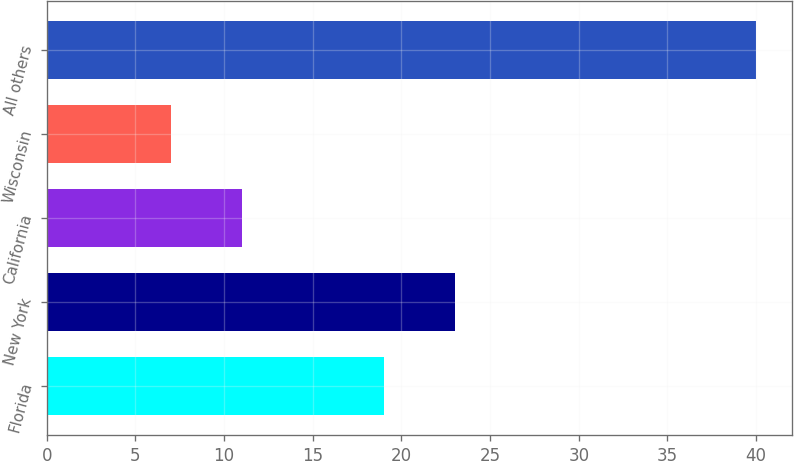Convert chart to OTSL. <chart><loc_0><loc_0><loc_500><loc_500><bar_chart><fcel>Florida<fcel>New York<fcel>California<fcel>Wisconsin<fcel>All others<nl><fcel>19<fcel>23<fcel>11<fcel>7<fcel>40<nl></chart> 